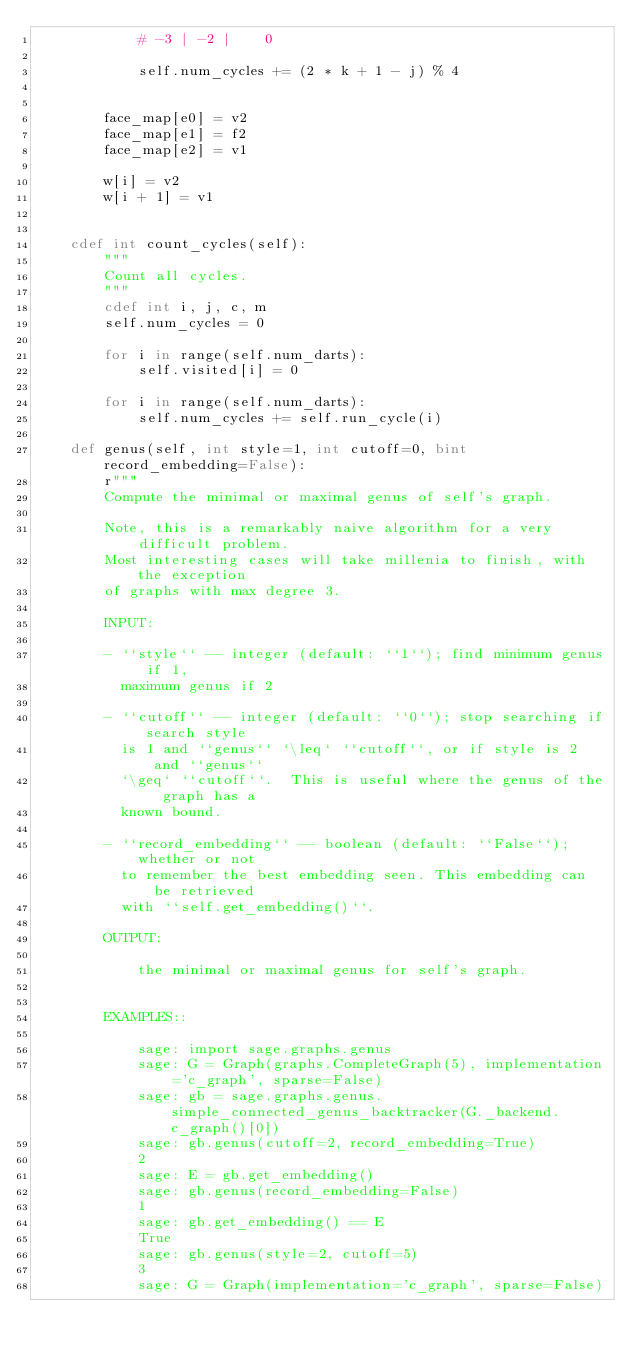Convert code to text. <code><loc_0><loc_0><loc_500><loc_500><_Cython_>            # -3 | -2 |    0

            self.num_cycles += (2 * k + 1 - j) % 4


        face_map[e0] = v2
        face_map[e1] = f2
        face_map[e2] = v1

        w[i] = v2
        w[i + 1] = v1


    cdef int count_cycles(self):
        """
        Count all cycles.
        """
        cdef int i, j, c, m
        self.num_cycles = 0

        for i in range(self.num_darts):
            self.visited[i] = 0

        for i in range(self.num_darts):
            self.num_cycles += self.run_cycle(i)

    def genus(self, int style=1, int cutoff=0, bint record_embedding=False):
        r"""
        Compute the minimal or maximal genus of self's graph.

        Note, this is a remarkably naive algorithm for a very difficult problem.
        Most interesting cases will take millenia to finish, with the exception
        of graphs with max degree 3.

        INPUT:

        - ``style`` -- integer (default: ``1``); find minimum genus if 1,
          maximum genus if 2

        - ``cutoff`` -- integer (default: ``0``); stop searching if search style
          is 1 and ``genus`` `\leq` ``cutoff``, or if style is 2 and ``genus``
          `\geq` ``cutoff``.  This is useful where the genus of the graph has a
          known bound.

        - ``record_embedding`` -- boolean (default: ``False``); whether or not
          to remember the best embedding seen. This embedding can be retrieved
          with ``self.get_embedding()``.

        OUTPUT:

            the minimal or maximal genus for self's graph.


        EXAMPLES::

            sage: import sage.graphs.genus
            sage: G = Graph(graphs.CompleteGraph(5), implementation='c_graph', sparse=False)
            sage: gb = sage.graphs.genus.simple_connected_genus_backtracker(G._backend.c_graph()[0])
            sage: gb.genus(cutoff=2, record_embedding=True)
            2
            sage: E = gb.get_embedding()
            sage: gb.genus(record_embedding=False)
            1
            sage: gb.get_embedding() == E
            True
            sage: gb.genus(style=2, cutoff=5)
            3
            sage: G = Graph(implementation='c_graph', sparse=False)</code> 